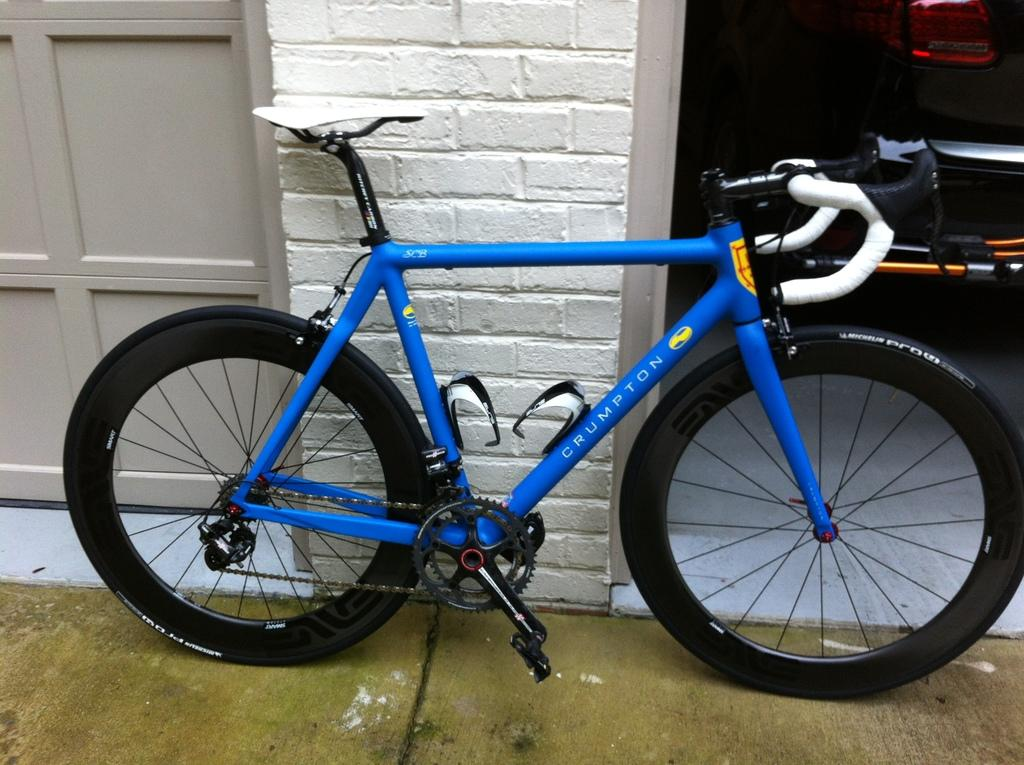What color is the bicycle in the image? The bicycle in the image is blue. What can be seen on the left side of the image? There is a white wall on the left side of the image. What is the purpose of the door in the image? The door in the image is likely for entering or exiting a building. What other objects are present on the right side of the image? There are other objects on the right side of the image, but their specific details are not mentioned in the provided facts. What type of fruit is hanging from the door in the image? There is no fruit present in the image, and therefore no such activity can be observed. 